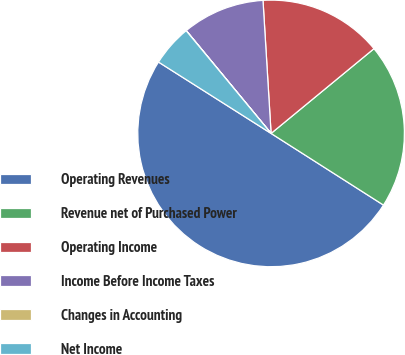<chart> <loc_0><loc_0><loc_500><loc_500><pie_chart><fcel>Operating Revenues<fcel>Revenue net of Purchased Power<fcel>Operating Income<fcel>Income Before Income Taxes<fcel>Changes in Accounting<fcel>Net Income<nl><fcel>49.96%<fcel>20.0%<fcel>15.0%<fcel>10.01%<fcel>0.02%<fcel>5.01%<nl></chart> 